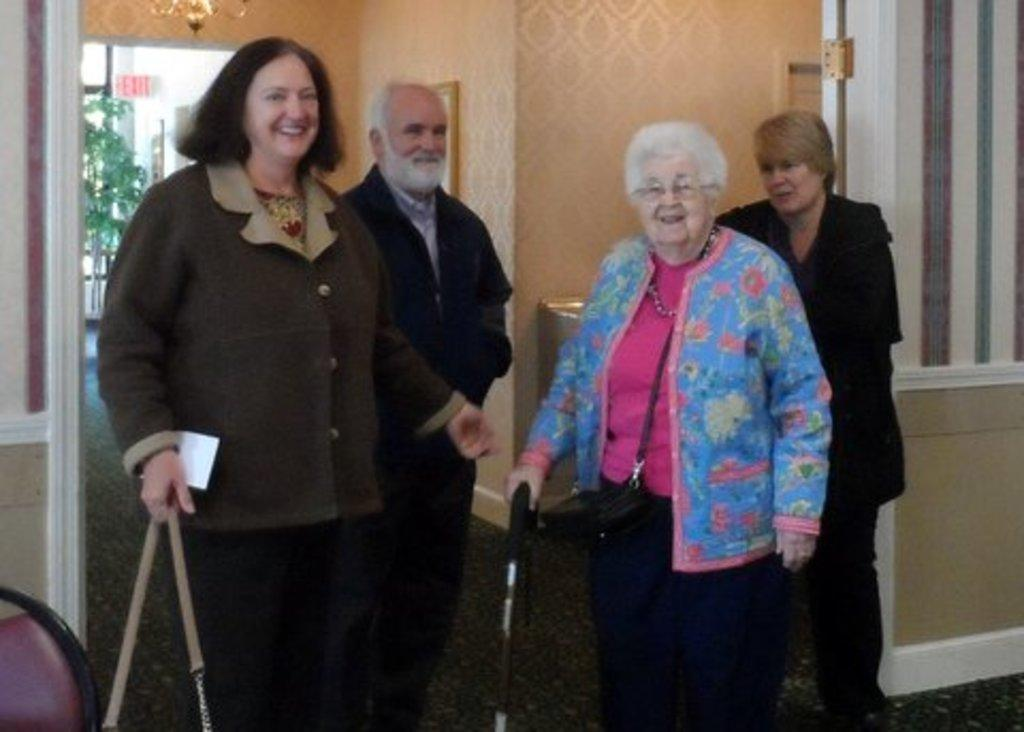Who is present in the image? There are people in the image, including women and a man. What is the facial expression of the people in the image? The people in the image are smiling. What can be seen in the background of the image? There is a green color wall in the background of the image. What scent can be detected in the image? There is no information about a scent in the image, as it is a visual medium. 